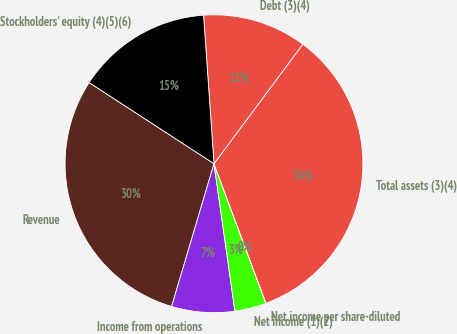Convert chart to OTSL. <chart><loc_0><loc_0><loc_500><loc_500><pie_chart><fcel>Revenue<fcel>Income from operations<fcel>Net income (1)(2)<fcel>Net income per share-diluted<fcel>Total assets (3)(4)<fcel>Debt (3)(4)<fcel>Stockholders' equity (4)(5)(6)<nl><fcel>29.58%<fcel>6.84%<fcel>3.43%<fcel>0.01%<fcel>34.15%<fcel>11.29%<fcel>14.71%<nl></chart> 